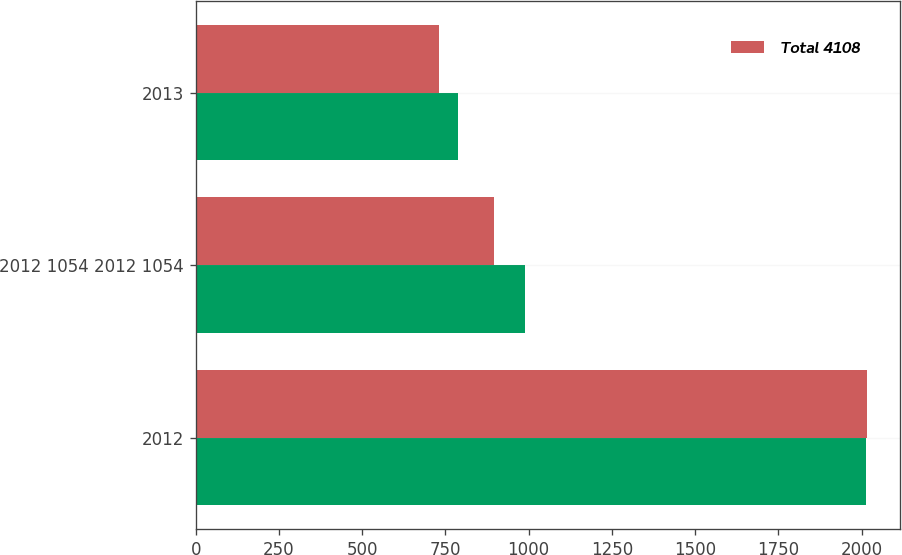Convert chart to OTSL. <chart><loc_0><loc_0><loc_500><loc_500><stacked_bar_chart><ecel><fcel>2012<fcel>2012 1054 2012 1054<fcel>2013<nl><fcel>nan<fcel>2013<fcel>988<fcel>789<nl><fcel>Total 4108<fcel>2016<fcel>895<fcel>731<nl></chart> 